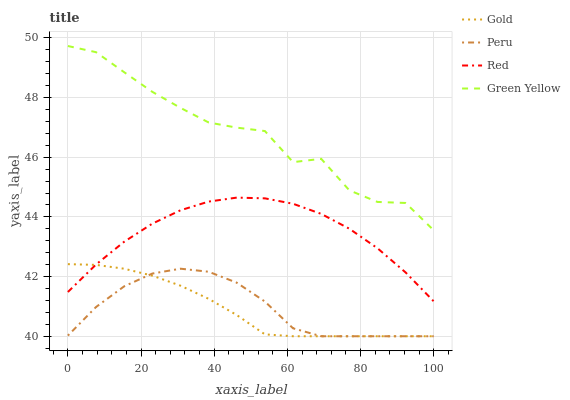Does Gold have the minimum area under the curve?
Answer yes or no. Yes. Does Green Yellow have the maximum area under the curve?
Answer yes or no. Yes. Does Peru have the minimum area under the curve?
Answer yes or no. No. Does Peru have the maximum area under the curve?
Answer yes or no. No. Is Gold the smoothest?
Answer yes or no. Yes. Is Green Yellow the roughest?
Answer yes or no. Yes. Is Peru the smoothest?
Answer yes or no. No. Is Peru the roughest?
Answer yes or no. No. Does Green Yellow have the lowest value?
Answer yes or no. No. Does Peru have the highest value?
Answer yes or no. No. Is Red less than Green Yellow?
Answer yes or no. Yes. Is Green Yellow greater than Red?
Answer yes or no. Yes. Does Red intersect Green Yellow?
Answer yes or no. No. 